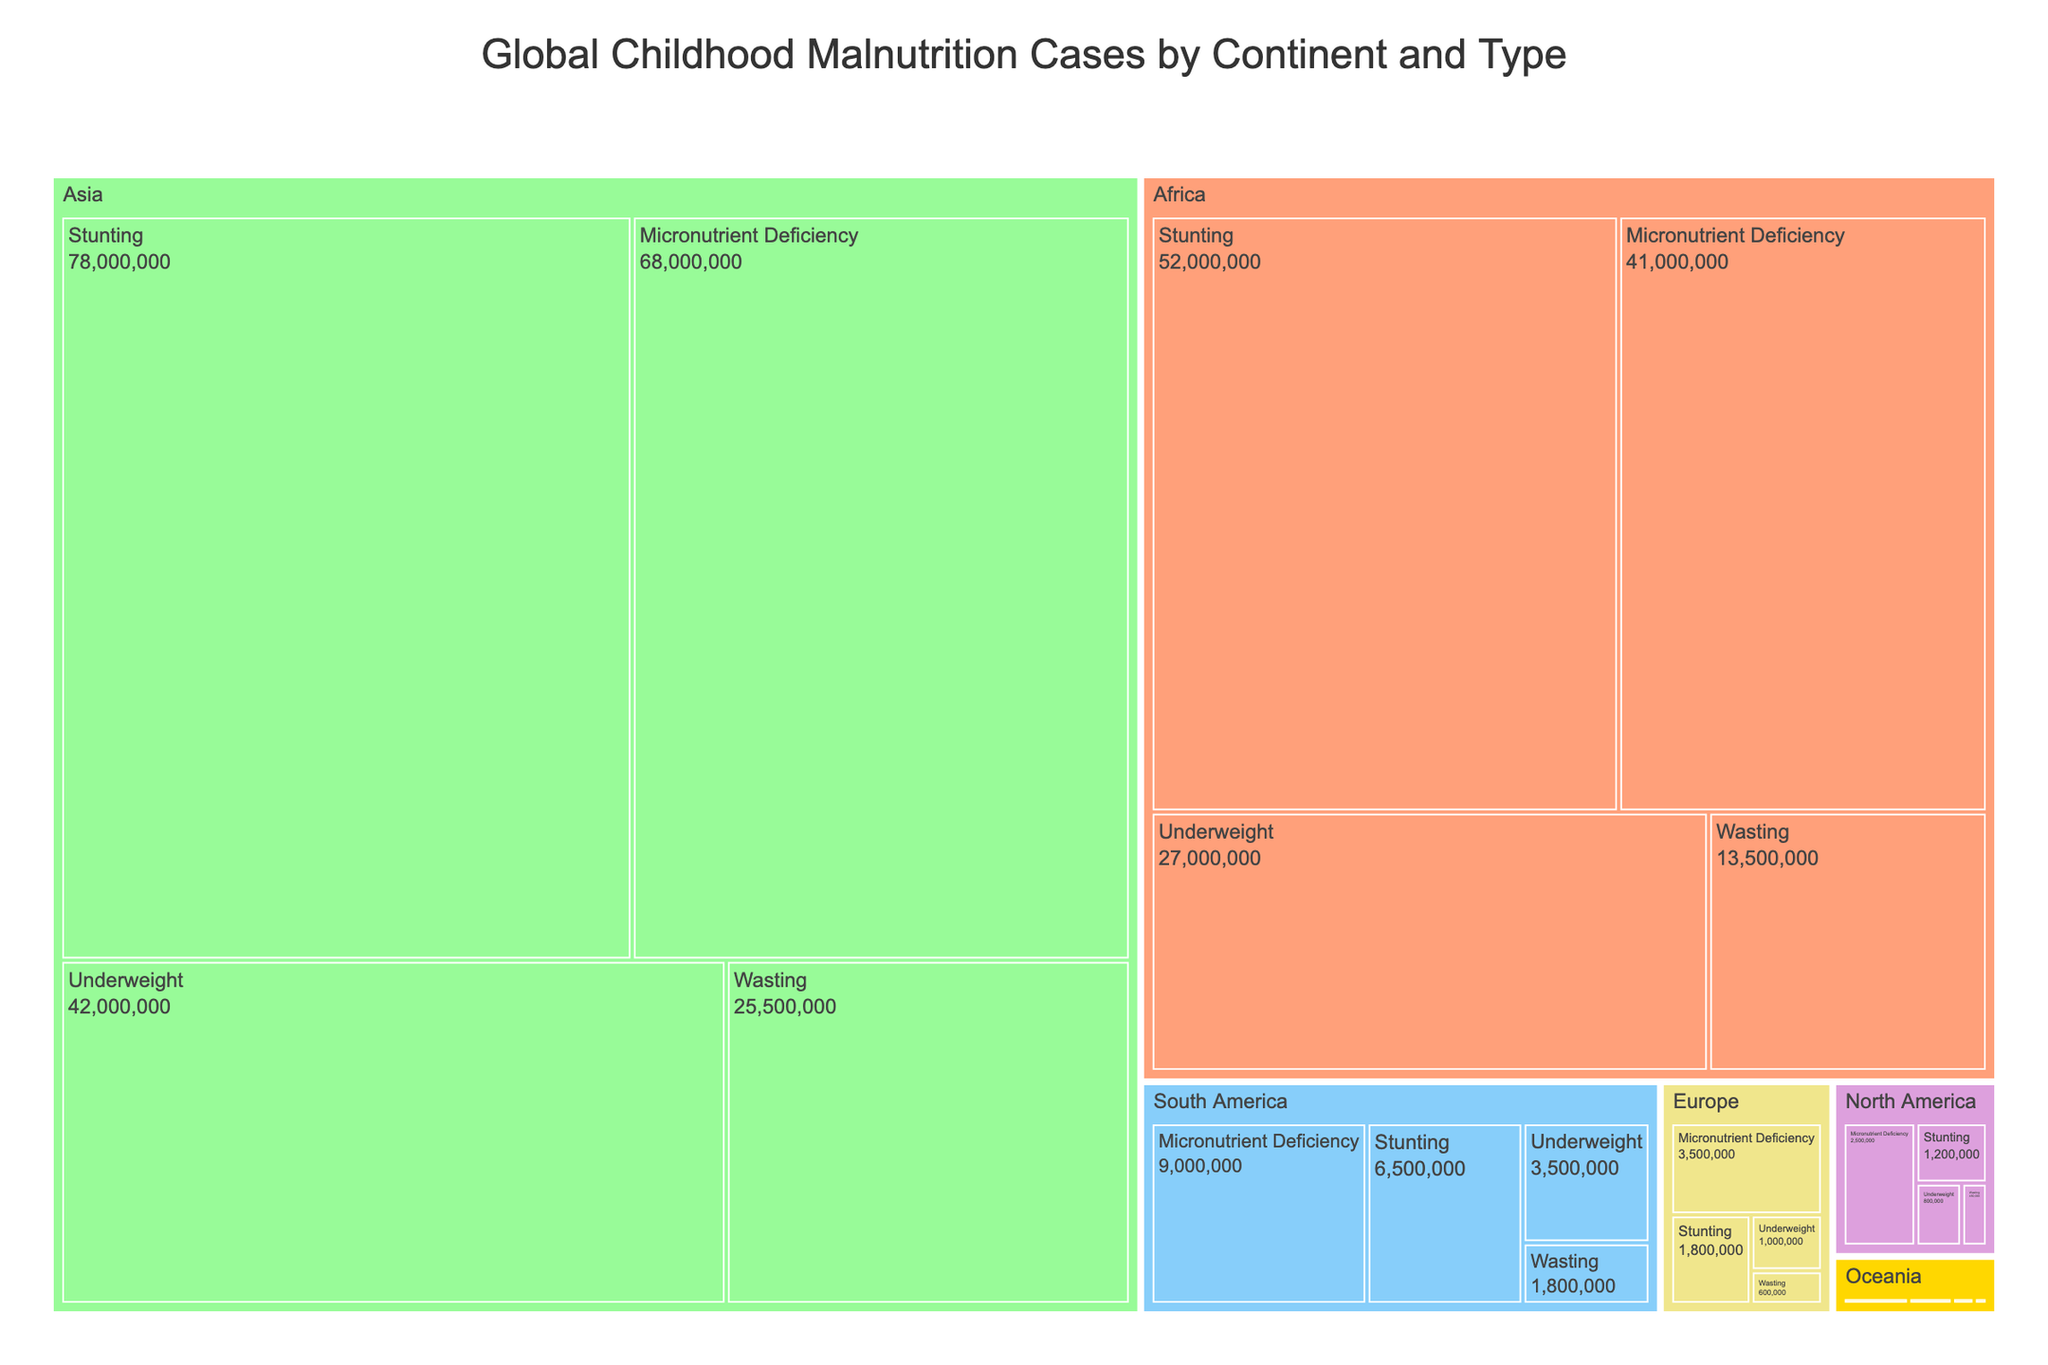What is the title of the treemap? The title is displayed at the top of the treemap.
Answer: Global Childhood Malnutrition Cases by Continent and Type How many malnutrition cases are there in Asia for stunting? Locate the section labeled "Asia" and then find the sub-category "Stunting" to see the number of cases.
Answer: 78,000,000 Which continent has the fewest cases of wasting? Compare the sections labeled "Wasting" across different continents and find the one with the smallest number.
Answer: Oceania What is the total number of malnutrition cases in South America? Sum the cases for all malnutrition types in the South America section: 6,500,000 (Stunting) + 1,800,000 (Wasting) + 3,500,000 (Underweight) + 9,000,000 (Micronutrient Deficiency).
Answer: 20,800,000 Which continent has the highest number of micronutrient deficiency cases? Compare the sections labeled "Micronutrient Deficiency" under each continent and find the one with the largest number.
Answer: Asia What is the difference in the number of underweight cases between Africa and Europe? Subtract the number of underweight cases in Europe from the number of underweight cases in Africa: 27,000,000 (Africa) - 1,000,000 (Europe).
Answer: 26,000,000 Which has more cases: stunting in Africa or underweight in Asia? Locate the number of cases for "Stunting" in Africa and "Underweight" in Asia, then compare them: Stunting in Africa (52,000,000) vs. Underweight in Asia (42,000,000).
Answer: Stunting in Africa What is the average number of malnutrition cases for micronutrient deficiency across all continents? Sum the micronutrient deficiency cases across all continents and divide by the number of continents: (41,000,000 + 68,000,000 + 9,000,000 + 2,500,000 + 3,500,000 + 750,000) / 6.
Answer: 20,125,000 Which continent has the smallest total number of malnutrition cases? Sum the total malnutrition cases for each continent and find the one with the smallest total: Oceania.
Answer: Oceania How many total malnutrition cases are there globally? Sum all malnutrition cases across all continents: 52,000,000 + 13,500,000 + 27,000,000 + 41,000,000 (Africa) + 78,000,000 + 25,500,000 + 42,000,000 + 68,000,000 (Asia) + 6,500,000 + 1,800,000 + 3,500,000 + 9,000,000 (South America) + 1,200,000 + 450,000 + 800,000 + 2,500,000 (North America) + 1,800,000 + 600,000 + 1,000,000 + 3,500,000 (Europe) + 500,000 + 150,000 + 250,000 + 750,000 (Oceania).
Answer: 377,300,000 